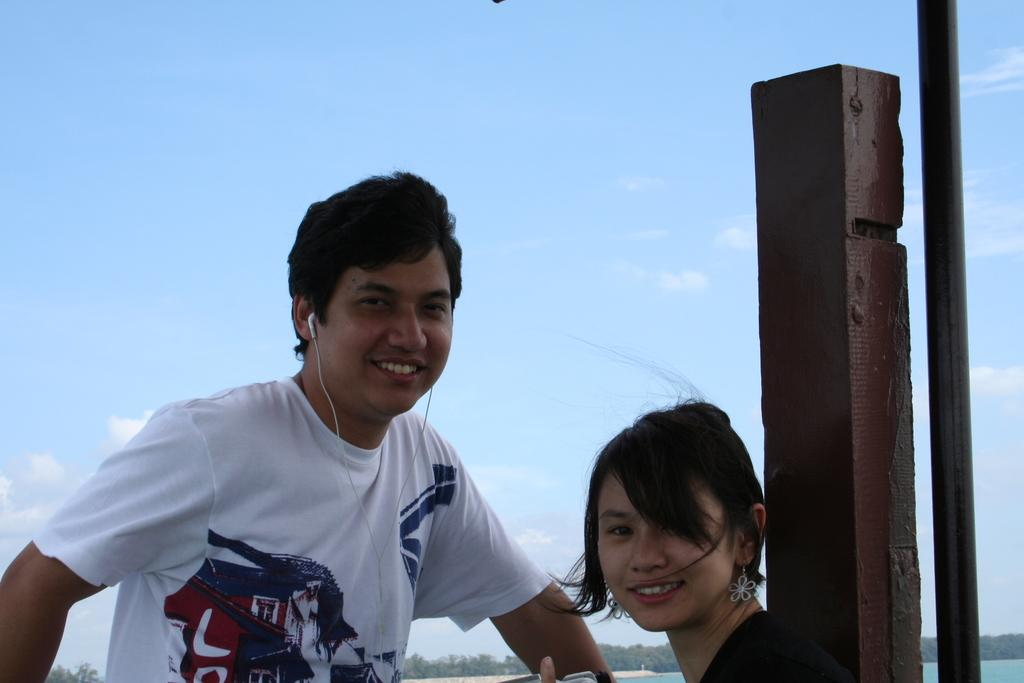How many people are in the image? There are two persons in the image. What is the facial expression of the persons in the image? The persons are smiling. What object can be seen in the image besides the people? There is an iron rod in the image. What natural element is visible in the image? There is water visible in the image. What type of vegetation is present in the image? There are trees in the image. What is visible in the background of the image? The sky is visible in the background of the image. Can you tell me how many tickets are visible in the image? There are no tickets present in the image. What type of ocean can be seen in the image? There is no ocean visible in the image. 